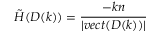<formula> <loc_0><loc_0><loc_500><loc_500>\tilde { H } ( D ( k ) ) = \frac { - k n } { | v e c t ( D ( k ) ) | }</formula> 